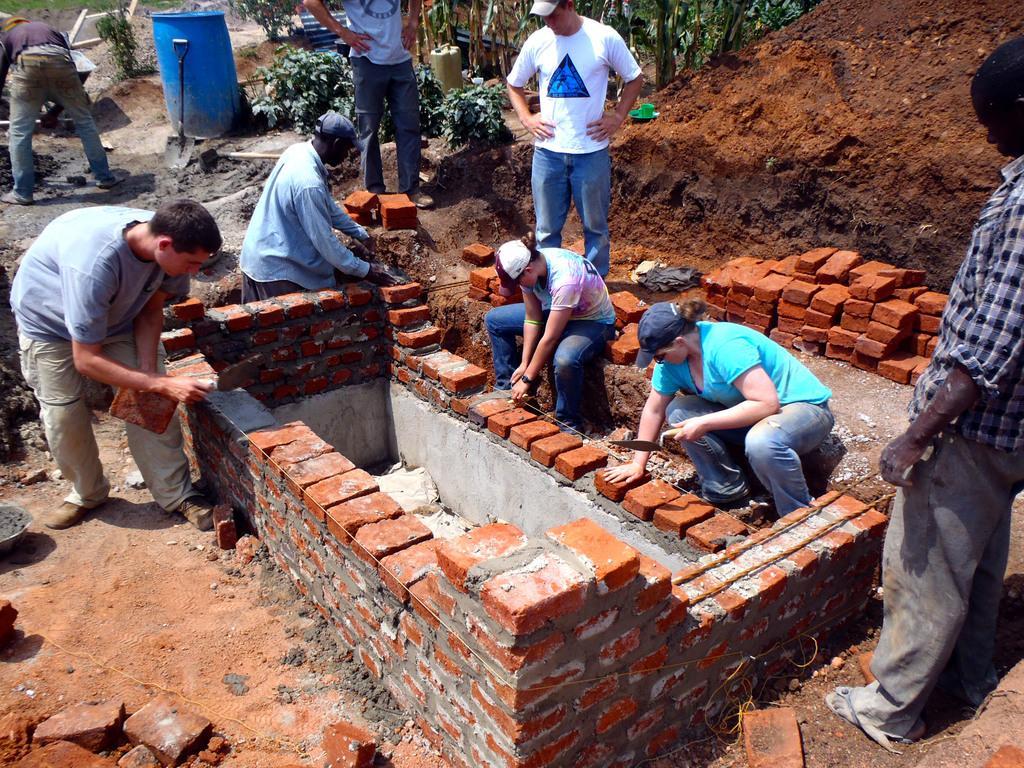Please provide a concise description of this image. In the image I can see some people who are constructing with the bricks and also I can see some plants, people, bricks and some sand. 